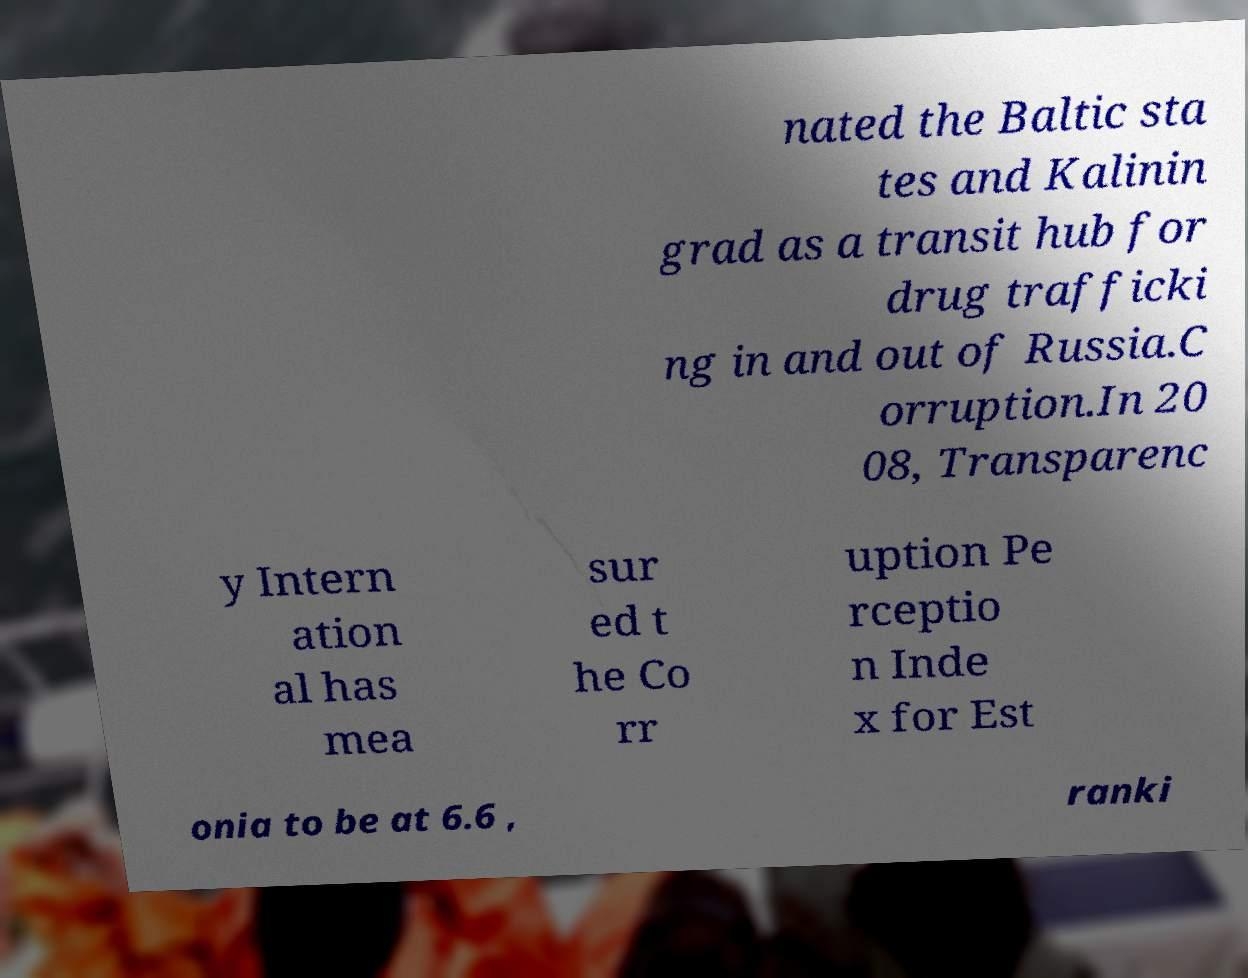For documentation purposes, I need the text within this image transcribed. Could you provide that? nated the Baltic sta tes and Kalinin grad as a transit hub for drug trafficki ng in and out of Russia.C orruption.In 20 08, Transparenc y Intern ation al has mea sur ed t he Co rr uption Pe rceptio n Inde x for Est onia to be at 6.6 , ranki 